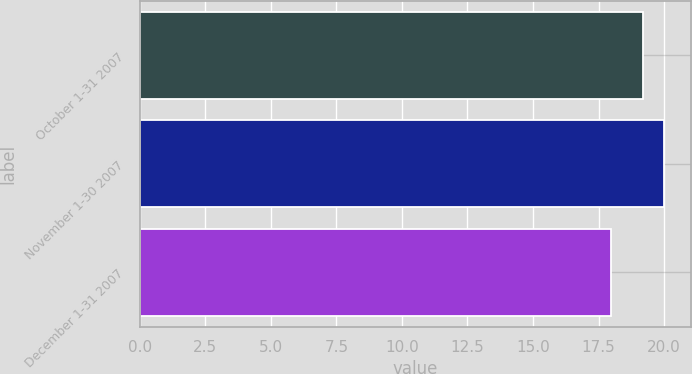<chart> <loc_0><loc_0><loc_500><loc_500><bar_chart><fcel>October 1-31 2007<fcel>November 1-30 2007<fcel>December 1-31 2007<nl><fcel>19.21<fcel>20.01<fcel>17.98<nl></chart> 